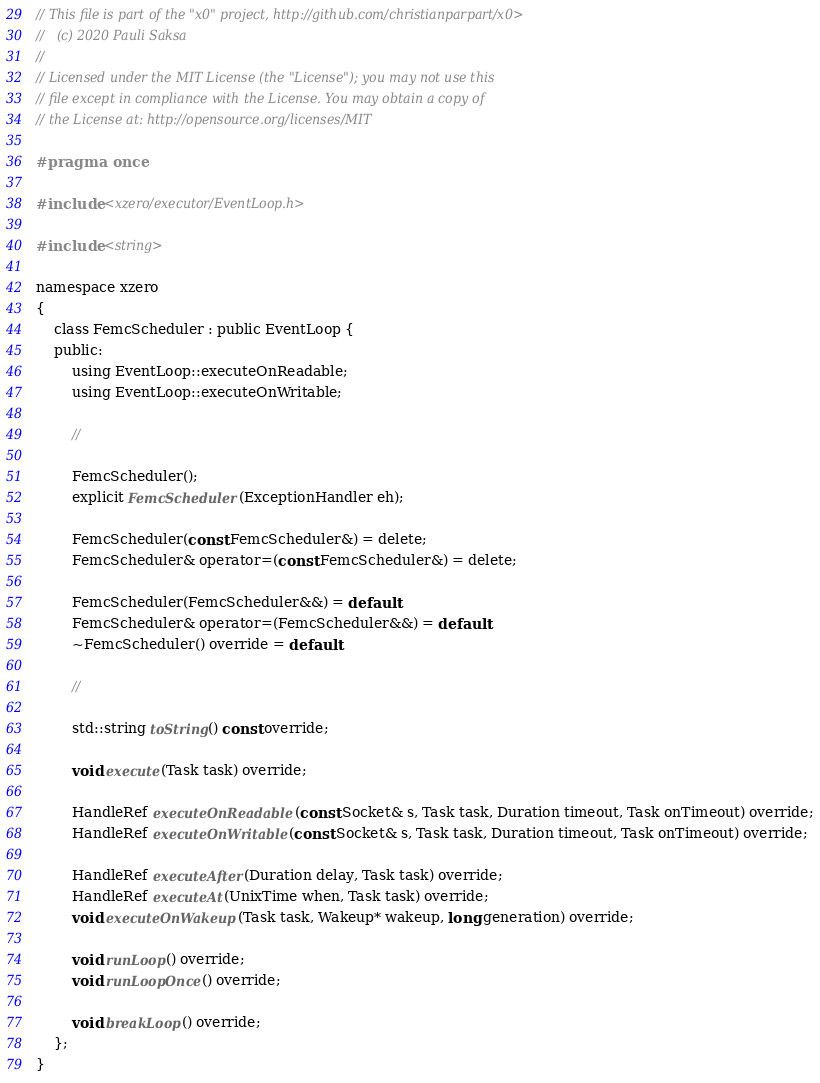<code> <loc_0><loc_0><loc_500><loc_500><_C_>// This file is part of the "x0" project, http://github.com/christianparpart/x0>
//   (c) 2020 Pauli Saksa
//
// Licensed under the MIT License (the "License"); you may not use this
// file except in compliance with the License. You may obtain a copy of
// the License at: http://opensource.org/licenses/MIT

#pragma once

#include <xzero/executor/EventLoop.h>

#include <string>

namespace xzero
{
    class FemcScheduler : public EventLoop {
    public:
        using EventLoop::executeOnReadable;
        using EventLoop::executeOnWritable;

        //

        FemcScheduler();
        explicit FemcScheduler(ExceptionHandler eh);

        FemcScheduler(const FemcScheduler&) = delete;
        FemcScheduler& operator=(const FemcScheduler&) = delete;

        FemcScheduler(FemcScheduler&&) = default;
        FemcScheduler& operator=(FemcScheduler&&) = default;
        ~FemcScheduler() override = default;

        //

        std::string toString() const override;

        void execute(Task task) override;

        HandleRef executeOnReadable(const Socket& s, Task task, Duration timeout, Task onTimeout) override;
        HandleRef executeOnWritable(const Socket& s, Task task, Duration timeout, Task onTimeout) override;

        HandleRef executeAfter(Duration delay, Task task) override;
        HandleRef executeAt(UnixTime when, Task task) override;
        void executeOnWakeup(Task task, Wakeup* wakeup, long generation) override;

        void runLoop() override;
        void runLoopOnce() override;

        void breakLoop() override;
    };
}
</code> 